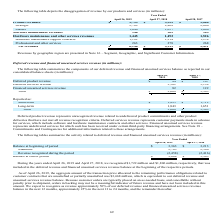From Netapp's financial document, Which years does the table provide information for the disaggregation of revenue by the company's products and services for? The document contains multiple relevant values: 2019, 2018, 2017. From the document: "April 26, 2019 April 27, 2018 April 28, 2017 April 26, 2019 April 27, 2018 April 28, 2017 April 26, 2019 April 27, 2018 April 28, 2017..." Also, What does both the company's Mature and Strategic product lines include? Based on the financial document, the answer is a mix of disk, hybrid and all flash storage media.. Also, What were the product revenues in 2019? According to the financial document, 3,755 (in millions). The relevant text states: "Product revenues $ 3,755 $ 3,525 $ 3,060..." Also, can you calculate: What was the change in the company's product revenue between 2017 and 2018? Based on the calculation: 3,525-3,060, the result is 465 (in millions). This is based on the information: "Product revenues $ 3,755 $ 3,525 $ 3,060 Product revenues $ 3,755 $ 3,525 $ 3,060..." The key data points involved are: 3,060, 3,525. Also, How many years did revenue from mature product lines exceed $1,000 million? Counting the relevant items in the document: 2019, 2018, 2017, I find 3 instances. The key data points involved are: 2017, 2018, 2019. Also, can you calculate: What was the percentage change in net revenues between 2018 and 2019? To answer this question, I need to perform calculations using the financial data. The calculation is: (6,146-5,919)/5,919, which equals 3.84 (percentage). This is based on the information: "Net revenues $ 6,146 $ 5,919 $ 5,491 Net revenues $ 6,146 $ 5,919 $ 5,491..." The key data points involved are: 5,919, 6,146. 